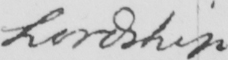Transcribe the text shown in this historical manuscript line. Lordship 